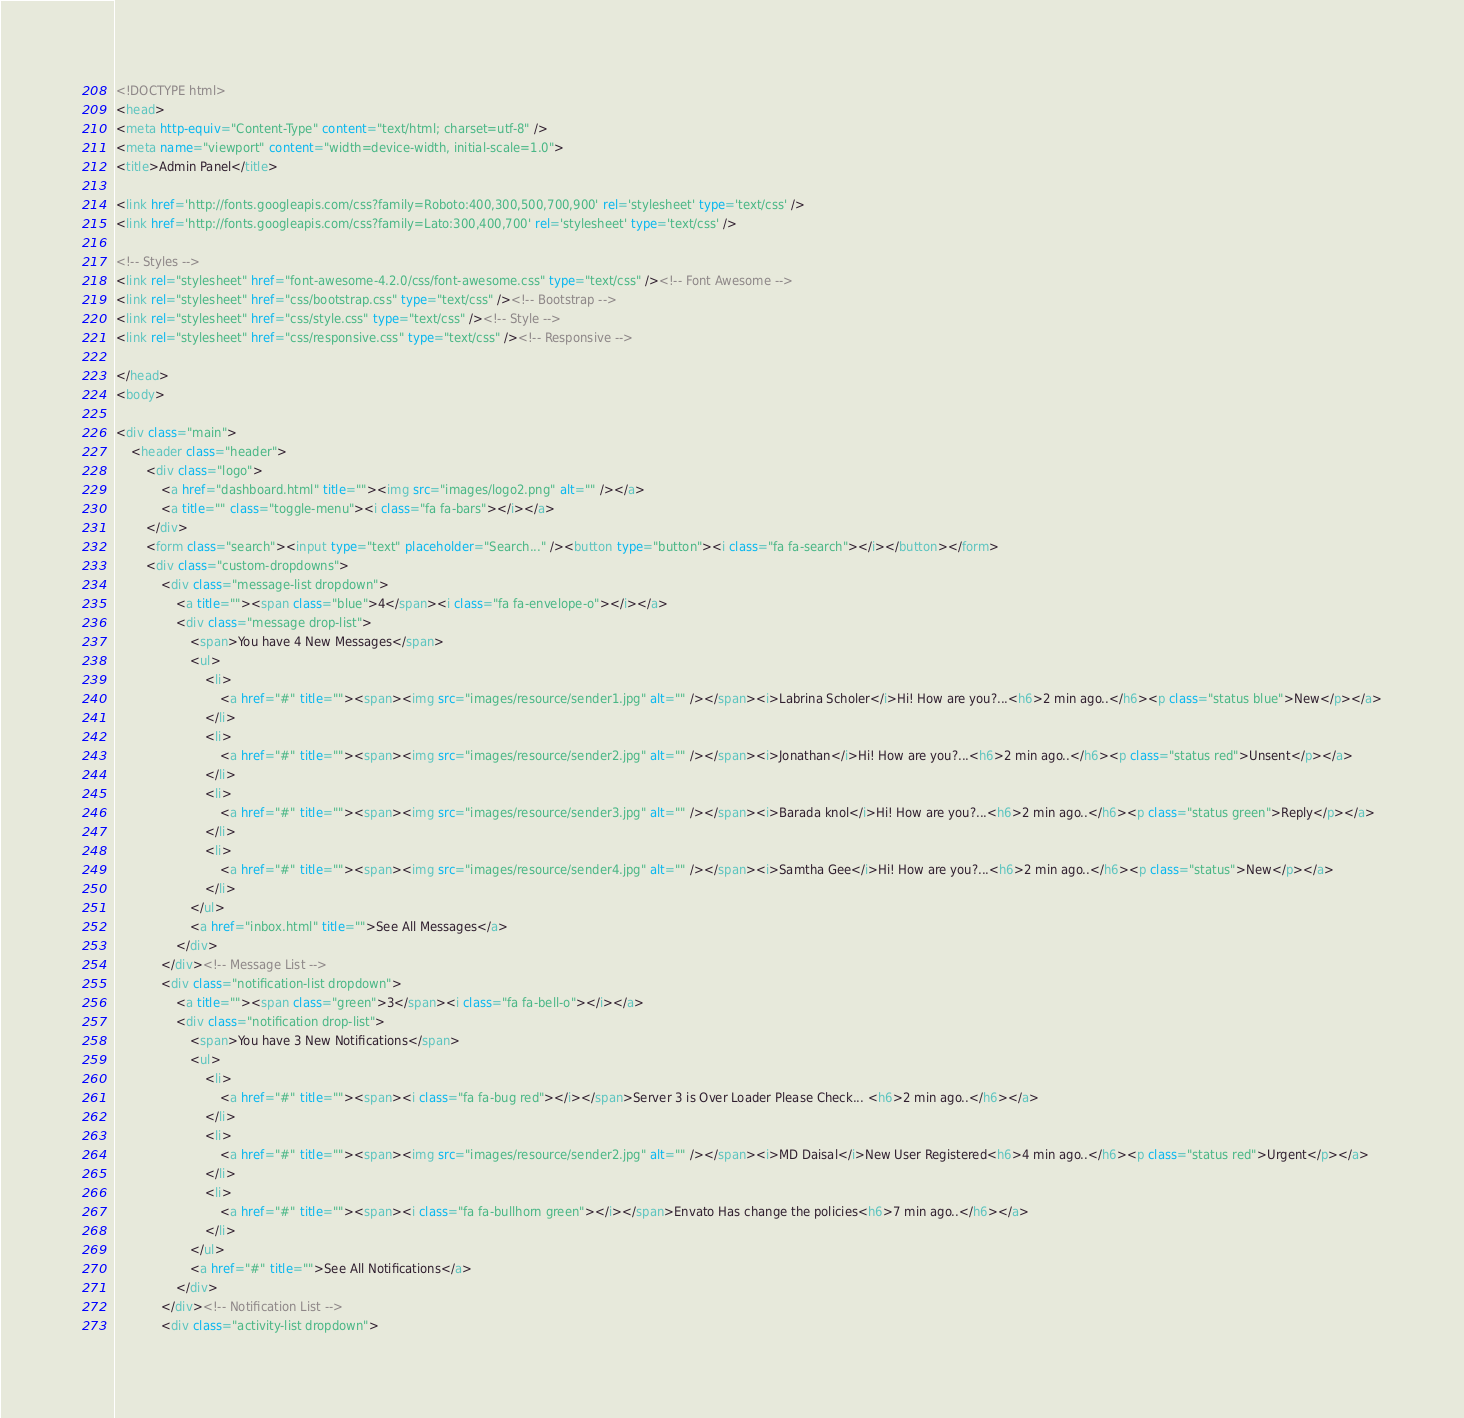<code> <loc_0><loc_0><loc_500><loc_500><_HTML_><!DOCTYPE html>
<head>
<meta http-equiv="Content-Type" content="text/html; charset=utf-8" />
<meta name="viewport" content="width=device-width, initial-scale=1.0">
<title>Admin Panel</title>

<link href='http://fonts.googleapis.com/css?family=Roboto:400,300,500,700,900' rel='stylesheet' type='text/css' />
<link href='http://fonts.googleapis.com/css?family=Lato:300,400,700' rel='stylesheet' type='text/css' />

<!-- Styles -->
<link rel="stylesheet" href="font-awesome-4.2.0/css/font-awesome.css" type="text/css" /><!-- Font Awesome -->
<link rel="stylesheet" href="css/bootstrap.css" type="text/css" /><!-- Bootstrap -->
<link rel="stylesheet" href="css/style.css" type="text/css" /><!-- Style -->
<link rel="stylesheet" href="css/responsive.css" type="text/css" /><!-- Responsive -->	

</head>
<body>

<div class="main">
	<header class="header">
		<div class="logo">
			<a href="dashboard.html" title=""><img src="images/logo2.png" alt="" /></a>
			<a title="" class="toggle-menu"><i class="fa fa-bars"></i></a>
		</div>
		<form class="search"><input type="text" placeholder="Search..." /><button type="button"><i class="fa fa-search"></i></button></form>
		<div class="custom-dropdowns">			
			<div class="message-list dropdown">
				<a title=""><span class="blue">4</span><i class="fa fa-envelope-o"></i></a>
				<div class="message drop-list">
					<span>You have 4 New Messages</span>
					<ul>
						<li>
							<a href="#" title=""><span><img src="images/resource/sender1.jpg" alt="" /></span><i>Labrina Scholer</i>Hi! How are you?...<h6>2 min ago..</h6><p class="status blue">New</p></a>
						</li>
						<li>
							<a href="#" title=""><span><img src="images/resource/sender2.jpg" alt="" /></span><i>Jonathan</i>Hi! How are you?...<h6>2 min ago..</h6><p class="status red">Unsent</p></a>
						</li>
						<li>
							<a href="#" title=""><span><img src="images/resource/sender3.jpg" alt="" /></span><i>Barada knol</i>Hi! How are you?...<h6>2 min ago..</h6><p class="status green">Reply</p></a>
						</li>
						<li>
							<a href="#" title=""><span><img src="images/resource/sender4.jpg" alt="" /></span><i>Samtha Gee</i>Hi! How are you?...<h6>2 min ago..</h6><p class="status">New</p></a>
						</li>
					</ul>
					<a href="inbox.html" title="">See All Messages</a>
				</div>
			</div><!-- Message List -->
			<div class="notification-list dropdown">
				<a title=""><span class="green">3</span><i class="fa fa-bell-o"></i></a>
				<div class="notification drop-list">
					<span>You have 3 New Notifications</span>
					<ul>
						<li>
							<a href="#" title=""><span><i class="fa fa-bug red"></i></span>Server 3 is Over Loader Please Check... <h6>2 min ago..</h6></a>
						</li>
						<li>
							<a href="#" title=""><span><img src="images/resource/sender2.jpg" alt="" /></span><i>MD Daisal</i>New User Registered<h6>4 min ago..</h6><p class="status red">Urgent</p></a>
						</li>
						<li>
							<a href="#" title=""><span><i class="fa fa-bullhorn green"></i></span>Envato Has change the policies<h6>7 min ago..</h6></a>
						</li>
					</ul>
					<a href="#" title="">See All Notifications</a>
				</div>
			</div><!-- Notification List -->
			<div class="activity-list dropdown"></code> 